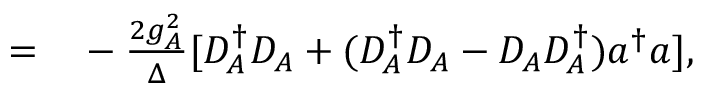Convert formula to latex. <formula><loc_0><loc_0><loc_500><loc_500>\begin{array} { r l } { = } & - \frac { 2 g _ { A } ^ { 2 } } { \Delta } [ D _ { A } ^ { \dagger } D _ { A } + ( D _ { A } ^ { \dagger } D _ { A } - D _ { A } D _ { A } ^ { \dagger } ) a ^ { \dagger } a ] , } \end{array}</formula> 